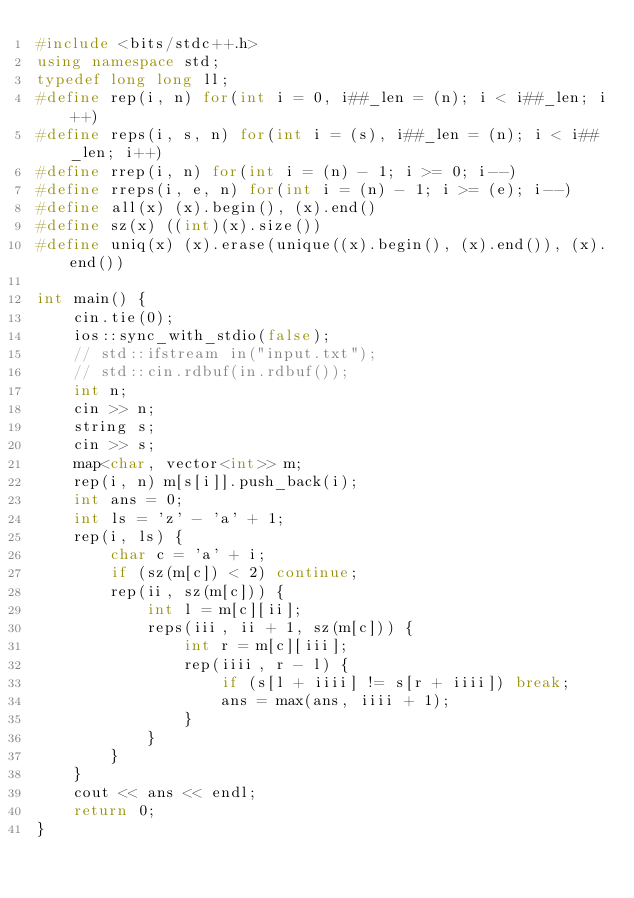<code> <loc_0><loc_0><loc_500><loc_500><_C++_>#include <bits/stdc++.h>
using namespace std;
typedef long long ll;
#define rep(i, n) for(int i = 0, i##_len = (n); i < i##_len; i++)
#define reps(i, s, n) for(int i = (s), i##_len = (n); i < i##_len; i++)
#define rrep(i, n) for(int i = (n) - 1; i >= 0; i--)
#define rreps(i, e, n) for(int i = (n) - 1; i >= (e); i--)
#define all(x) (x).begin(), (x).end()
#define sz(x) ((int)(x).size())
#define uniq(x) (x).erase(unique((x).begin(), (x).end()), (x).end())

int main() {
    cin.tie(0);
    ios::sync_with_stdio(false);
    // std::ifstream in("input.txt");
    // std::cin.rdbuf(in.rdbuf());
    int n;
    cin >> n;
    string s;
    cin >> s;
    map<char, vector<int>> m;
    rep(i, n) m[s[i]].push_back(i);
    int ans = 0;
    int ls = 'z' - 'a' + 1;
    rep(i, ls) {
        char c = 'a' + i;
        if (sz(m[c]) < 2) continue;
        rep(ii, sz(m[c])) {
            int l = m[c][ii];
            reps(iii, ii + 1, sz(m[c])) {
                int r = m[c][iii];
                rep(iiii, r - l) {
                    if (s[l + iiii] != s[r + iiii]) break;
                    ans = max(ans, iiii + 1);
                }
            }
        }
    }
    cout << ans << endl;
    return 0;
}
</code> 